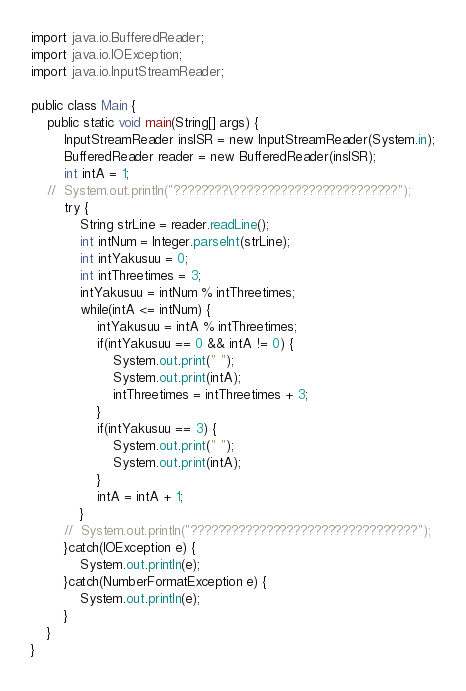Convert code to text. <code><loc_0><loc_0><loc_500><loc_500><_Java_>import java.io.BufferedReader;
import java.io.IOException;
import java.io.InputStreamReader;

public class Main {
	public static void main(String[] args) {
		InputStreamReader insISR = new InputStreamReader(System.in);
		BufferedReader reader = new BufferedReader(insISR);
		int intA = 1;
	//	System.out.println("????????\????????????????????????");
		try {
			String strLine = reader.readLine();
			int intNum = Integer.parseInt(strLine);
			int intYakusuu = 0;
			int intThreetimes = 3;
			intYakusuu = intNum % intThreetimes;
			while(intA <= intNum) {
				intYakusuu = intA % intThreetimes;
				if(intYakusuu == 0 && intA != 0) {
					System.out.print(" ");
					System.out.print(intA);
					intThreetimes = intThreetimes + 3;
				}
				if(intYakusuu == 3) {
					System.out.print(" ");
					System.out.print(intA);
				}
				intA = intA + 1;
			}
		//	System.out.println("?????????????????????????????????");
		}catch(IOException e) {
			System.out.println(e);
		}catch(NumberFormatException e) {
			System.out.println(e);
		}
	}
}</code> 